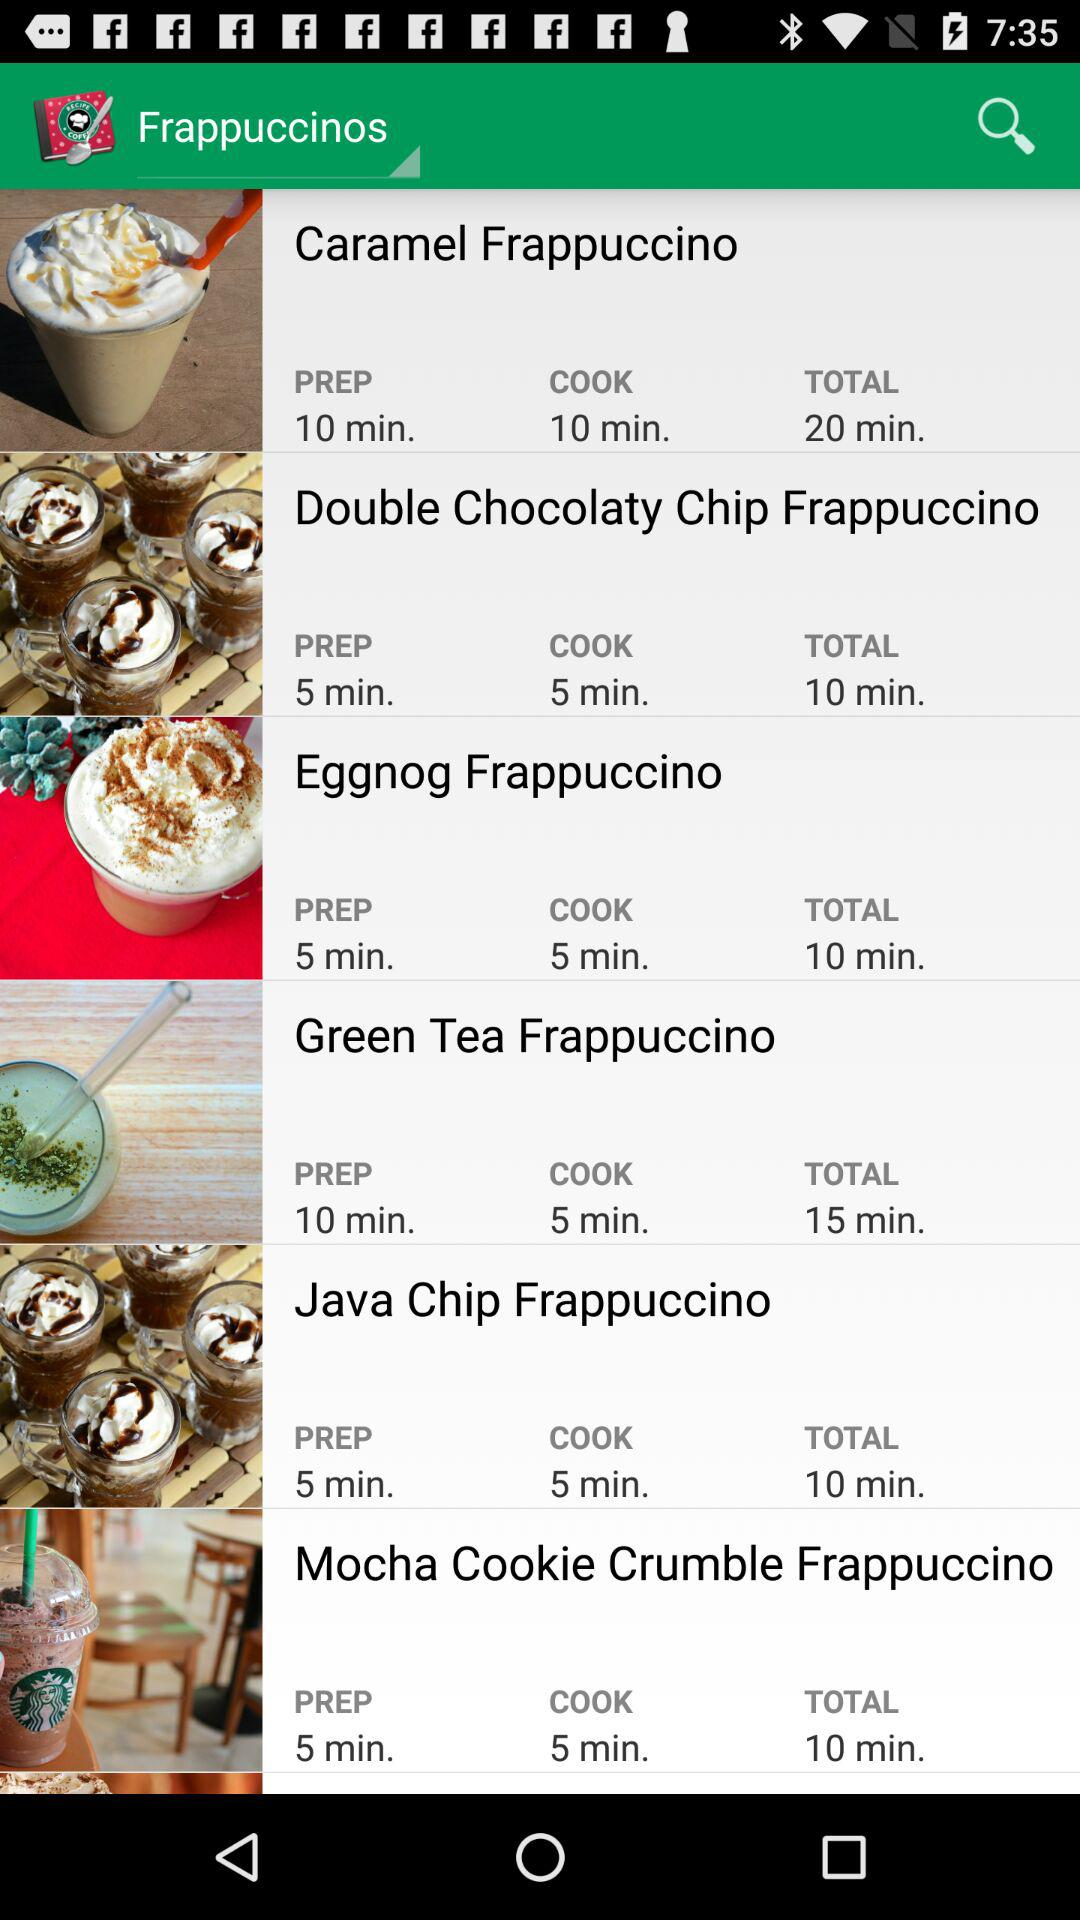How many frappuccinos have a prep time of 5 minutes?
Answer the question using a single word or phrase. 4 